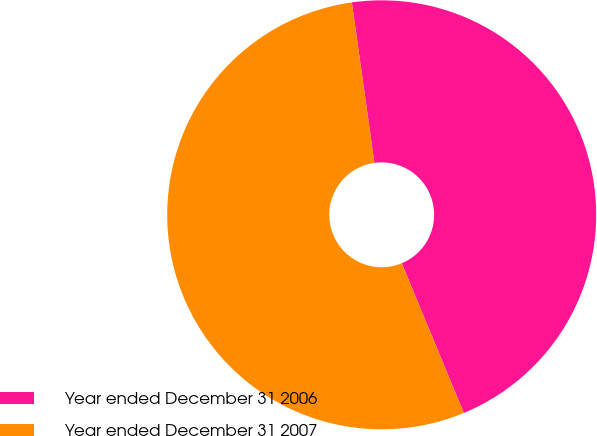Convert chart. <chart><loc_0><loc_0><loc_500><loc_500><pie_chart><fcel>Year ended December 31 2006<fcel>Year ended December 31 2007<nl><fcel>45.97%<fcel>54.03%<nl></chart> 